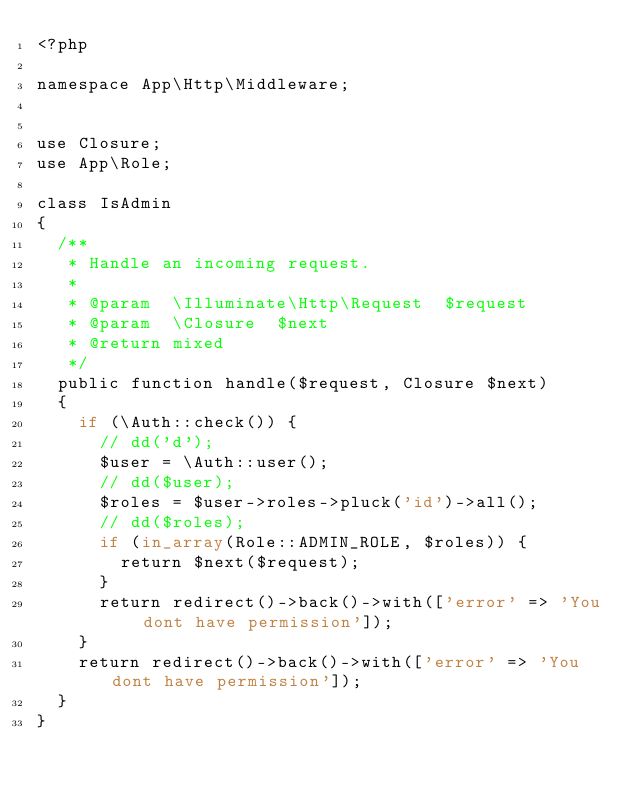Convert code to text. <code><loc_0><loc_0><loc_500><loc_500><_PHP_><?php

namespace App\Http\Middleware;


use Closure;
use App\Role;

class IsAdmin
{
  /**
   * Handle an incoming request.
   *
   * @param  \Illuminate\Http\Request  $request
   * @param  \Closure  $next
   * @return mixed
   */
  public function handle($request, Closure $next)
  {
    if (\Auth::check()) {
      // dd('d');
      $user = \Auth::user();
      // dd($user);
      $roles = $user->roles->pluck('id')->all();
      // dd($roles);
      if (in_array(Role::ADMIN_ROLE, $roles)) {
        return $next($request);
      }
      return redirect()->back()->with(['error' => 'You dont have permission']);
    }
    return redirect()->back()->with(['error' => 'You dont have permission']);
  }
}
</code> 